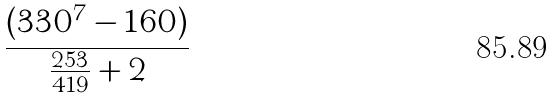Convert formula to latex. <formula><loc_0><loc_0><loc_500><loc_500>\frac { ( 3 3 0 ^ { 7 } - 1 6 0 ) } { \frac { 2 5 3 } { 4 1 9 } + 2 }</formula> 